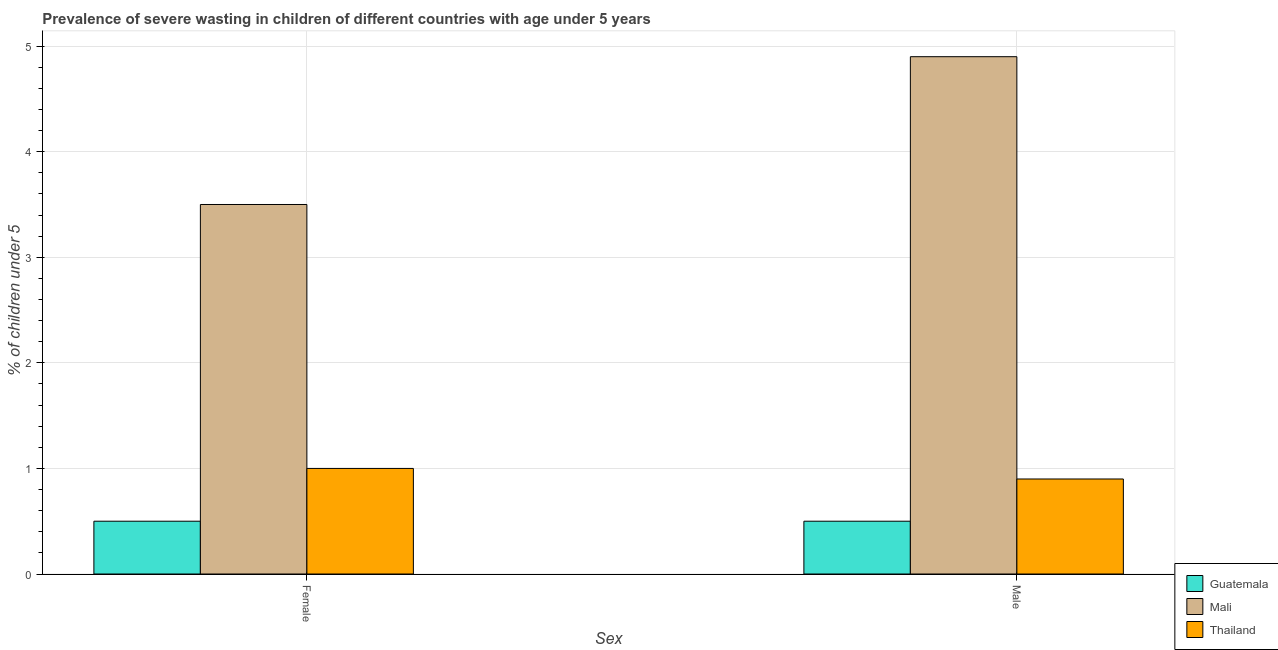Are the number of bars on each tick of the X-axis equal?
Your answer should be compact. Yes. What is the percentage of undernourished male children in Mali?
Provide a succinct answer. 4.9. Across all countries, what is the maximum percentage of undernourished female children?
Your answer should be compact. 3.5. Across all countries, what is the minimum percentage of undernourished male children?
Keep it short and to the point. 0.5. In which country was the percentage of undernourished female children maximum?
Your answer should be very brief. Mali. In which country was the percentage of undernourished female children minimum?
Ensure brevity in your answer.  Guatemala. What is the total percentage of undernourished female children in the graph?
Provide a succinct answer. 5. What is the difference between the percentage of undernourished female children in Guatemala and that in Thailand?
Your answer should be very brief. -0.5. What is the difference between the percentage of undernourished female children in Guatemala and the percentage of undernourished male children in Thailand?
Ensure brevity in your answer.  -0.4. What is the average percentage of undernourished male children per country?
Your response must be concise. 2.1. What is the difference between the percentage of undernourished male children and percentage of undernourished female children in Mali?
Ensure brevity in your answer.  1.4. In how many countries, is the percentage of undernourished female children greater than 3 %?
Your answer should be compact. 1. What is the ratio of the percentage of undernourished male children in Guatemala to that in Thailand?
Provide a short and direct response. 0.56. In how many countries, is the percentage of undernourished male children greater than the average percentage of undernourished male children taken over all countries?
Offer a very short reply. 1. What does the 3rd bar from the left in Female represents?
Ensure brevity in your answer.  Thailand. What does the 2nd bar from the right in Female represents?
Your answer should be compact. Mali. Are all the bars in the graph horizontal?
Give a very brief answer. No. What is the difference between two consecutive major ticks on the Y-axis?
Offer a terse response. 1. What is the title of the graph?
Offer a very short reply. Prevalence of severe wasting in children of different countries with age under 5 years. Does "Micronesia" appear as one of the legend labels in the graph?
Provide a succinct answer. No. What is the label or title of the X-axis?
Make the answer very short. Sex. What is the label or title of the Y-axis?
Your response must be concise.  % of children under 5. What is the  % of children under 5 in Mali in Female?
Ensure brevity in your answer.  3.5. What is the  % of children under 5 of Thailand in Female?
Offer a very short reply. 1. What is the  % of children under 5 of Guatemala in Male?
Keep it short and to the point. 0.5. What is the  % of children under 5 of Mali in Male?
Offer a very short reply. 4.9. What is the  % of children under 5 in Thailand in Male?
Provide a succinct answer. 0.9. Across all Sex, what is the maximum  % of children under 5 in Guatemala?
Make the answer very short. 0.5. Across all Sex, what is the maximum  % of children under 5 of Mali?
Your answer should be compact. 4.9. Across all Sex, what is the maximum  % of children under 5 in Thailand?
Give a very brief answer. 1. Across all Sex, what is the minimum  % of children under 5 in Thailand?
Keep it short and to the point. 0.9. What is the total  % of children under 5 of Mali in the graph?
Offer a terse response. 8.4. What is the total  % of children under 5 of Thailand in the graph?
Keep it short and to the point. 1.9. What is the difference between the  % of children under 5 in Guatemala in Female and that in Male?
Offer a very short reply. 0. What is the difference between the  % of children under 5 of Guatemala in Female and the  % of children under 5 of Mali in Male?
Ensure brevity in your answer.  -4.4. What is the difference between the  % of children under 5 in Guatemala in Female and the  % of children under 5 in Thailand in Male?
Make the answer very short. -0.4. What is the difference between the  % of children under 5 of Mali in Female and the  % of children under 5 of Thailand in Male?
Give a very brief answer. 2.6. What is the average  % of children under 5 in Guatemala per Sex?
Offer a terse response. 0.5. What is the average  % of children under 5 of Thailand per Sex?
Your response must be concise. 0.95. What is the difference between the  % of children under 5 of Guatemala and  % of children under 5 of Thailand in Female?
Provide a succinct answer. -0.5. What is the difference between the  % of children under 5 of Mali and  % of children under 5 of Thailand in Female?
Ensure brevity in your answer.  2.5. What is the difference between the  % of children under 5 in Guatemala and  % of children under 5 in Thailand in Male?
Offer a terse response. -0.4. What is the difference between the  % of children under 5 in Mali and  % of children under 5 in Thailand in Male?
Provide a succinct answer. 4. What is the ratio of the  % of children under 5 in Mali in Female to that in Male?
Give a very brief answer. 0.71. What is the difference between the highest and the second highest  % of children under 5 in Guatemala?
Your response must be concise. 0. What is the difference between the highest and the second highest  % of children under 5 in Mali?
Offer a terse response. 1.4. What is the difference between the highest and the second highest  % of children under 5 in Thailand?
Your answer should be very brief. 0.1. What is the difference between the highest and the lowest  % of children under 5 in Guatemala?
Provide a short and direct response. 0. What is the difference between the highest and the lowest  % of children under 5 of Mali?
Make the answer very short. 1.4. 